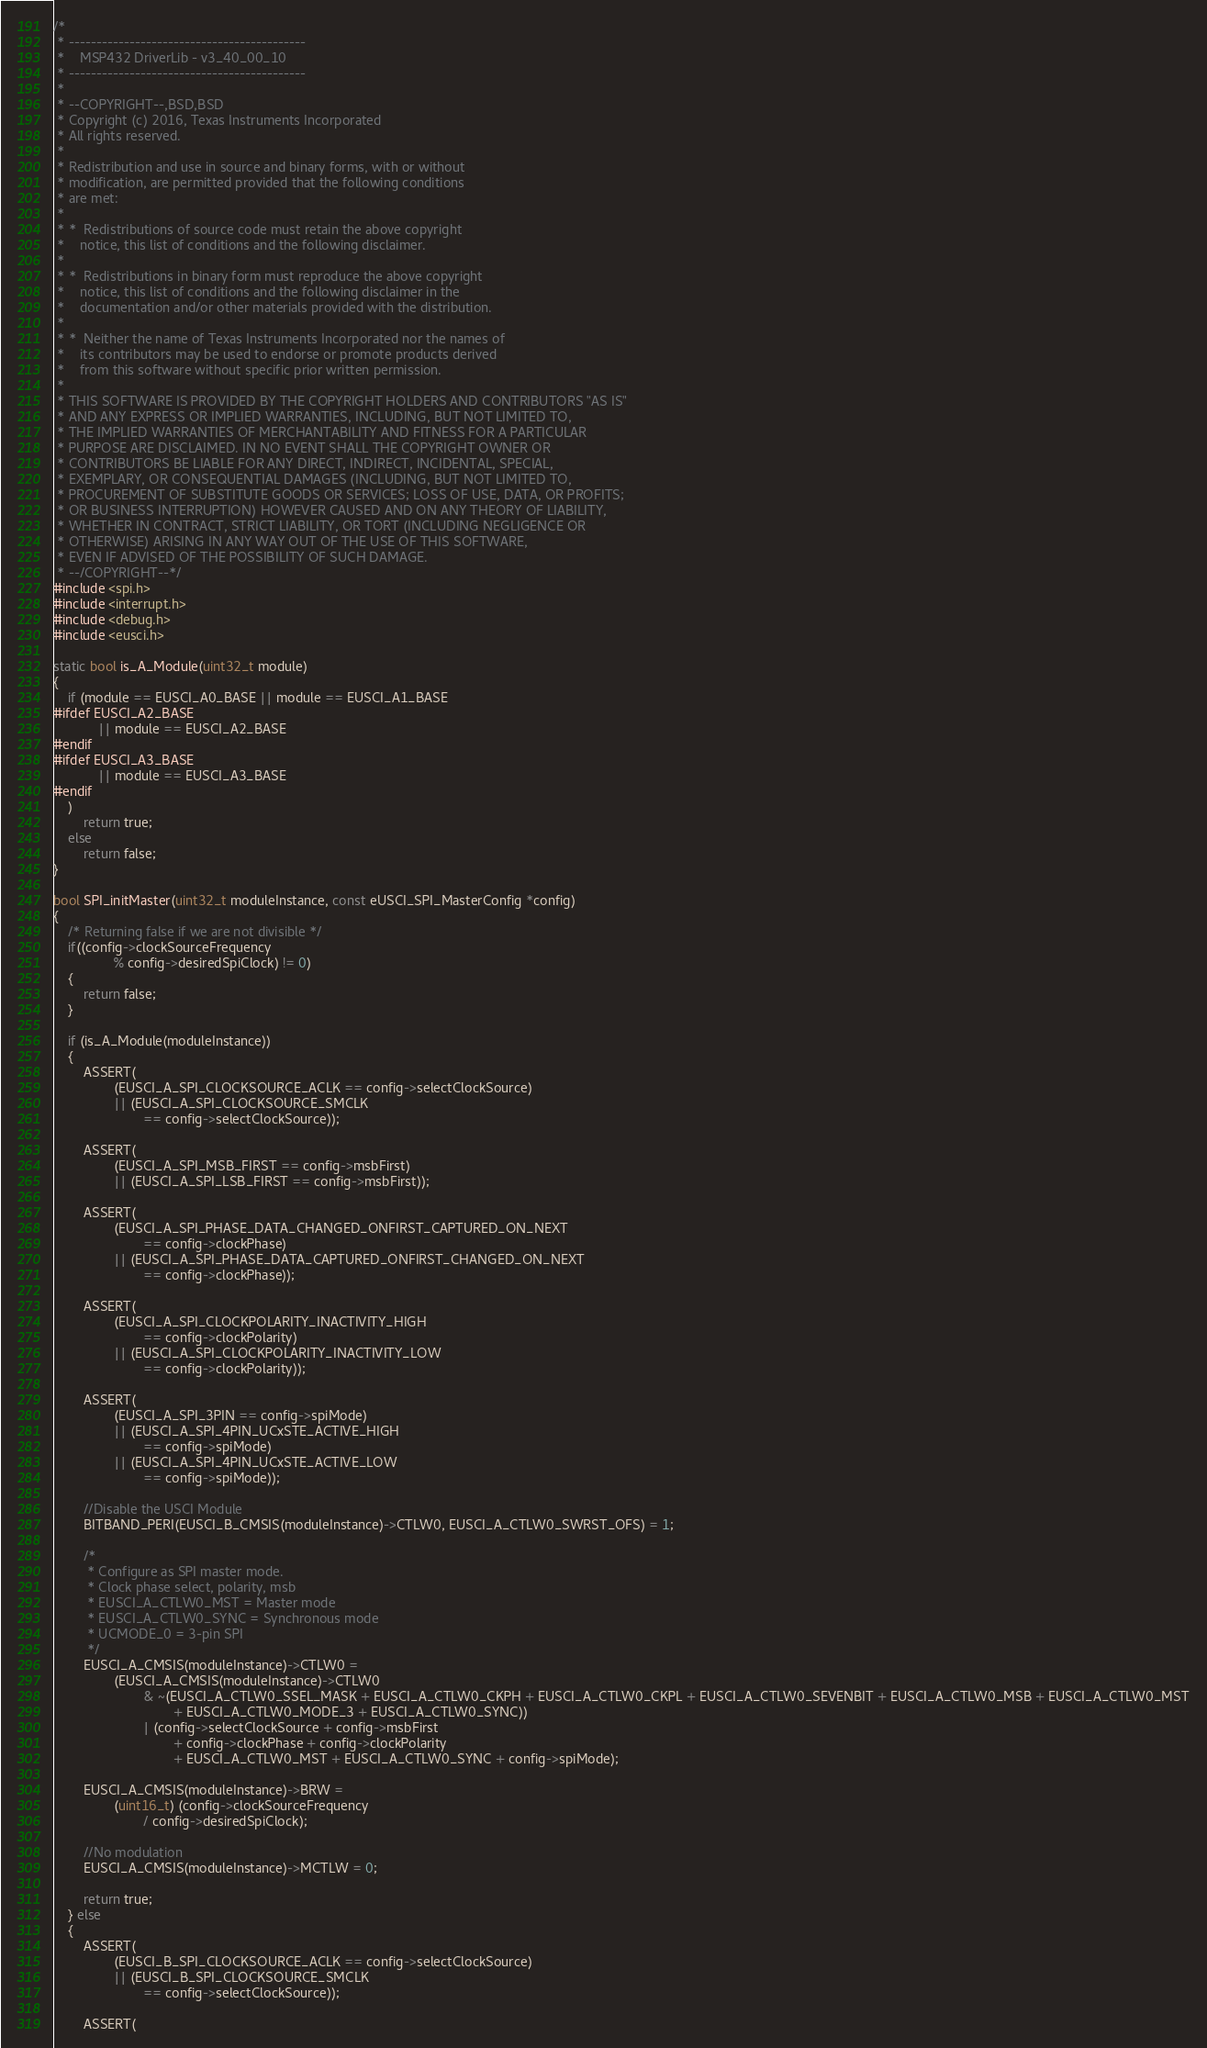Convert code to text. <code><loc_0><loc_0><loc_500><loc_500><_C_>/*
 * -------------------------------------------
 *    MSP432 DriverLib - v3_40_00_10 
 * -------------------------------------------
 *
 * --COPYRIGHT--,BSD,BSD
 * Copyright (c) 2016, Texas Instruments Incorporated
 * All rights reserved.
 *
 * Redistribution and use in source and binary forms, with or without
 * modification, are permitted provided that the following conditions
 * are met:
 *
 * *  Redistributions of source code must retain the above copyright
 *    notice, this list of conditions and the following disclaimer.
 *
 * *  Redistributions in binary form must reproduce the above copyright
 *    notice, this list of conditions and the following disclaimer in the
 *    documentation and/or other materials provided with the distribution.
 *
 * *  Neither the name of Texas Instruments Incorporated nor the names of
 *    its contributors may be used to endorse or promote products derived
 *    from this software without specific prior written permission.
 *
 * THIS SOFTWARE IS PROVIDED BY THE COPYRIGHT HOLDERS AND CONTRIBUTORS "AS IS"
 * AND ANY EXPRESS OR IMPLIED WARRANTIES, INCLUDING, BUT NOT LIMITED TO,
 * THE IMPLIED WARRANTIES OF MERCHANTABILITY AND FITNESS FOR A PARTICULAR
 * PURPOSE ARE DISCLAIMED. IN NO EVENT SHALL THE COPYRIGHT OWNER OR
 * CONTRIBUTORS BE LIABLE FOR ANY DIRECT, INDIRECT, INCIDENTAL, SPECIAL,
 * EXEMPLARY, OR CONSEQUENTIAL DAMAGES (INCLUDING, BUT NOT LIMITED TO,
 * PROCUREMENT OF SUBSTITUTE GOODS OR SERVICES; LOSS OF USE, DATA, OR PROFITS;
 * OR BUSINESS INTERRUPTION) HOWEVER CAUSED AND ON ANY THEORY OF LIABILITY,
 * WHETHER IN CONTRACT, STRICT LIABILITY, OR TORT (INCLUDING NEGLIGENCE OR
 * OTHERWISE) ARISING IN ANY WAY OUT OF THE USE OF THIS SOFTWARE,
 * EVEN IF ADVISED OF THE POSSIBILITY OF SUCH DAMAGE.
 * --/COPYRIGHT--*/
#include <spi.h>
#include <interrupt.h>
#include <debug.h>
#include <eusci.h>

static bool is_A_Module(uint32_t module)
{
    if (module == EUSCI_A0_BASE || module == EUSCI_A1_BASE
#ifdef EUSCI_A2_BASE
            || module == EUSCI_A2_BASE
#endif
#ifdef EUSCI_A3_BASE
            || module == EUSCI_A3_BASE
#endif
    )
        return true;
    else
        return false;
}

bool SPI_initMaster(uint32_t moduleInstance, const eUSCI_SPI_MasterConfig *config)
{
    /* Returning false if we are not divisible */
    if((config->clockSourceFrequency
                % config->desiredSpiClock) != 0)
    {
        return false;
    }
    
    if (is_A_Module(moduleInstance))
    {
        ASSERT(
                (EUSCI_A_SPI_CLOCKSOURCE_ACLK == config->selectClockSource)
                || (EUSCI_A_SPI_CLOCKSOURCE_SMCLK
                        == config->selectClockSource));

        ASSERT(
                (EUSCI_A_SPI_MSB_FIRST == config->msbFirst)
                || (EUSCI_A_SPI_LSB_FIRST == config->msbFirst));

        ASSERT(
                (EUSCI_A_SPI_PHASE_DATA_CHANGED_ONFIRST_CAPTURED_ON_NEXT
                        == config->clockPhase)
                || (EUSCI_A_SPI_PHASE_DATA_CAPTURED_ONFIRST_CHANGED_ON_NEXT
                        == config->clockPhase));

        ASSERT(
                (EUSCI_A_SPI_CLOCKPOLARITY_INACTIVITY_HIGH
                        == config->clockPolarity)
                || (EUSCI_A_SPI_CLOCKPOLARITY_INACTIVITY_LOW
                        == config->clockPolarity));

        ASSERT(
                (EUSCI_A_SPI_3PIN == config->spiMode)
                || (EUSCI_A_SPI_4PIN_UCxSTE_ACTIVE_HIGH
                        == config->spiMode)
                || (EUSCI_A_SPI_4PIN_UCxSTE_ACTIVE_LOW
                        == config->spiMode));
                        
        //Disable the USCI Module
        BITBAND_PERI(EUSCI_B_CMSIS(moduleInstance)->CTLW0, EUSCI_A_CTLW0_SWRST_OFS) = 1;

        /*
         * Configure as SPI master mode.
         * Clock phase select, polarity, msb
         * EUSCI_A_CTLW0_MST = Master mode
         * EUSCI_A_CTLW0_SYNC = Synchronous mode
         * UCMODE_0 = 3-pin SPI
         */
        EUSCI_A_CMSIS(moduleInstance)->CTLW0 =
                (EUSCI_A_CMSIS(moduleInstance)->CTLW0
                        & ~(EUSCI_A_CTLW0_SSEL_MASK + EUSCI_A_CTLW0_CKPH + EUSCI_A_CTLW0_CKPL + EUSCI_A_CTLW0_SEVENBIT + EUSCI_A_CTLW0_MSB + EUSCI_A_CTLW0_MST
                                + EUSCI_A_CTLW0_MODE_3 + EUSCI_A_CTLW0_SYNC))
                        | (config->selectClockSource + config->msbFirst
                                + config->clockPhase + config->clockPolarity
                                + EUSCI_A_CTLW0_MST + EUSCI_A_CTLW0_SYNC + config->spiMode);
        
        EUSCI_A_CMSIS(moduleInstance)->BRW =
                (uint16_t) (config->clockSourceFrequency
                        / config->desiredSpiClock);

        //No modulation
        EUSCI_A_CMSIS(moduleInstance)->MCTLW = 0;

        return true;
    } else
    {
        ASSERT(
                (EUSCI_B_SPI_CLOCKSOURCE_ACLK == config->selectClockSource)
                || (EUSCI_B_SPI_CLOCKSOURCE_SMCLK
                        == config->selectClockSource));

        ASSERT(</code> 